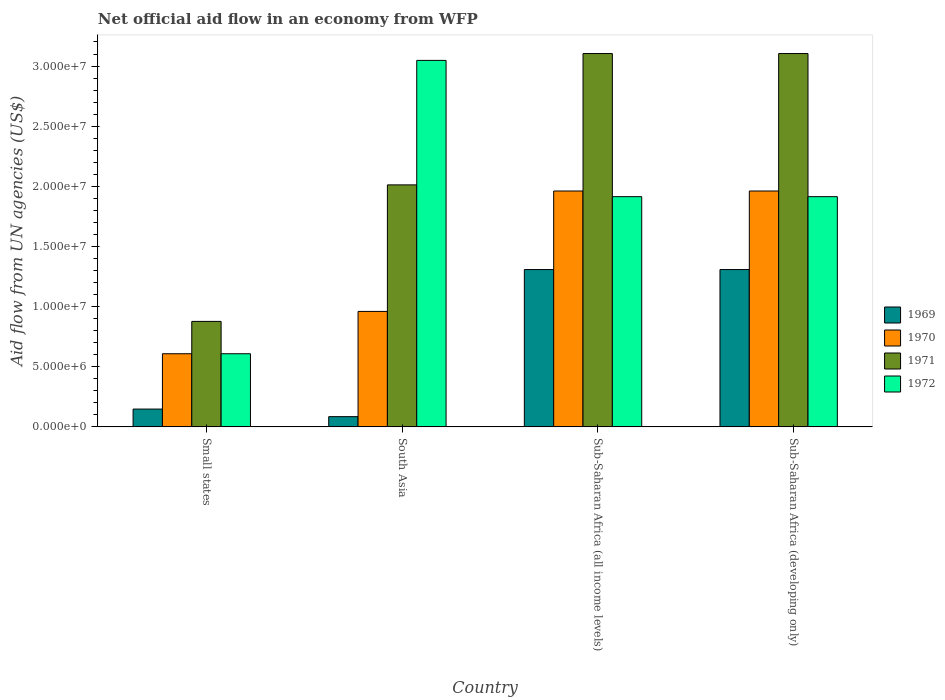Are the number of bars on each tick of the X-axis equal?
Make the answer very short. Yes. In how many cases, is the number of bars for a given country not equal to the number of legend labels?
Give a very brief answer. 0. What is the net official aid flow in 1970 in Small states?
Provide a short and direct response. 6.08e+06. Across all countries, what is the maximum net official aid flow in 1970?
Your response must be concise. 1.96e+07. Across all countries, what is the minimum net official aid flow in 1970?
Give a very brief answer. 6.08e+06. In which country was the net official aid flow in 1970 maximum?
Offer a terse response. Sub-Saharan Africa (all income levels). In which country was the net official aid flow in 1970 minimum?
Your answer should be very brief. Small states. What is the total net official aid flow in 1972 in the graph?
Make the answer very short. 7.48e+07. What is the difference between the net official aid flow in 1972 in Small states and that in South Asia?
Ensure brevity in your answer.  -2.44e+07. What is the difference between the net official aid flow in 1971 in Sub-Saharan Africa (all income levels) and the net official aid flow in 1969 in Small states?
Make the answer very short. 2.96e+07. What is the average net official aid flow in 1969 per country?
Give a very brief answer. 7.12e+06. What is the difference between the net official aid flow of/in 1972 and net official aid flow of/in 1971 in South Asia?
Your response must be concise. 1.04e+07. What is the ratio of the net official aid flow in 1972 in South Asia to that in Sub-Saharan Africa (all income levels)?
Your answer should be very brief. 1.59. Is the net official aid flow in 1970 in South Asia less than that in Sub-Saharan Africa (all income levels)?
Give a very brief answer. Yes. What is the difference between the highest and the second highest net official aid flow in 1971?
Your answer should be compact. 1.09e+07. What is the difference between the highest and the lowest net official aid flow in 1971?
Ensure brevity in your answer.  2.23e+07. Is the sum of the net official aid flow in 1970 in Small states and South Asia greater than the maximum net official aid flow in 1969 across all countries?
Ensure brevity in your answer.  Yes. Is it the case that in every country, the sum of the net official aid flow in 1969 and net official aid flow in 1970 is greater than the sum of net official aid flow in 1971 and net official aid flow in 1972?
Give a very brief answer. No. What does the 2nd bar from the right in South Asia represents?
Make the answer very short. 1971. Is it the case that in every country, the sum of the net official aid flow in 1972 and net official aid flow in 1969 is greater than the net official aid flow in 1970?
Your answer should be very brief. Yes. How many bars are there?
Your answer should be compact. 16. Are all the bars in the graph horizontal?
Offer a very short reply. No. Does the graph contain grids?
Provide a succinct answer. No. Where does the legend appear in the graph?
Offer a terse response. Center right. How many legend labels are there?
Your answer should be very brief. 4. How are the legend labels stacked?
Your answer should be very brief. Vertical. What is the title of the graph?
Offer a very short reply. Net official aid flow in an economy from WFP. Does "1974" appear as one of the legend labels in the graph?
Offer a terse response. No. What is the label or title of the X-axis?
Ensure brevity in your answer.  Country. What is the label or title of the Y-axis?
Your answer should be very brief. Aid flow from UN agencies (US$). What is the Aid flow from UN agencies (US$) in 1969 in Small states?
Keep it short and to the point. 1.48e+06. What is the Aid flow from UN agencies (US$) in 1970 in Small states?
Ensure brevity in your answer.  6.08e+06. What is the Aid flow from UN agencies (US$) in 1971 in Small states?
Your response must be concise. 8.77e+06. What is the Aid flow from UN agencies (US$) of 1972 in Small states?
Make the answer very short. 6.08e+06. What is the Aid flow from UN agencies (US$) of 1969 in South Asia?
Offer a terse response. 8.50e+05. What is the Aid flow from UN agencies (US$) of 1970 in South Asia?
Provide a succinct answer. 9.60e+06. What is the Aid flow from UN agencies (US$) in 1971 in South Asia?
Offer a very short reply. 2.01e+07. What is the Aid flow from UN agencies (US$) in 1972 in South Asia?
Your response must be concise. 3.05e+07. What is the Aid flow from UN agencies (US$) in 1969 in Sub-Saharan Africa (all income levels)?
Offer a terse response. 1.31e+07. What is the Aid flow from UN agencies (US$) in 1970 in Sub-Saharan Africa (all income levels)?
Your response must be concise. 1.96e+07. What is the Aid flow from UN agencies (US$) in 1971 in Sub-Saharan Africa (all income levels)?
Make the answer very short. 3.10e+07. What is the Aid flow from UN agencies (US$) in 1972 in Sub-Saharan Africa (all income levels)?
Make the answer very short. 1.91e+07. What is the Aid flow from UN agencies (US$) in 1969 in Sub-Saharan Africa (developing only)?
Keep it short and to the point. 1.31e+07. What is the Aid flow from UN agencies (US$) in 1970 in Sub-Saharan Africa (developing only)?
Your answer should be very brief. 1.96e+07. What is the Aid flow from UN agencies (US$) in 1971 in Sub-Saharan Africa (developing only)?
Your response must be concise. 3.10e+07. What is the Aid flow from UN agencies (US$) in 1972 in Sub-Saharan Africa (developing only)?
Your answer should be compact. 1.91e+07. Across all countries, what is the maximum Aid flow from UN agencies (US$) in 1969?
Your response must be concise. 1.31e+07. Across all countries, what is the maximum Aid flow from UN agencies (US$) in 1970?
Offer a terse response. 1.96e+07. Across all countries, what is the maximum Aid flow from UN agencies (US$) of 1971?
Offer a very short reply. 3.10e+07. Across all countries, what is the maximum Aid flow from UN agencies (US$) of 1972?
Ensure brevity in your answer.  3.05e+07. Across all countries, what is the minimum Aid flow from UN agencies (US$) of 1969?
Provide a short and direct response. 8.50e+05. Across all countries, what is the minimum Aid flow from UN agencies (US$) in 1970?
Your answer should be compact. 6.08e+06. Across all countries, what is the minimum Aid flow from UN agencies (US$) in 1971?
Make the answer very short. 8.77e+06. Across all countries, what is the minimum Aid flow from UN agencies (US$) in 1972?
Offer a terse response. 6.08e+06. What is the total Aid flow from UN agencies (US$) of 1969 in the graph?
Offer a terse response. 2.85e+07. What is the total Aid flow from UN agencies (US$) of 1970 in the graph?
Offer a very short reply. 5.49e+07. What is the total Aid flow from UN agencies (US$) of 1971 in the graph?
Ensure brevity in your answer.  9.10e+07. What is the total Aid flow from UN agencies (US$) of 1972 in the graph?
Give a very brief answer. 7.48e+07. What is the difference between the Aid flow from UN agencies (US$) of 1969 in Small states and that in South Asia?
Your answer should be compact. 6.30e+05. What is the difference between the Aid flow from UN agencies (US$) in 1970 in Small states and that in South Asia?
Your answer should be compact. -3.52e+06. What is the difference between the Aid flow from UN agencies (US$) in 1971 in Small states and that in South Asia?
Give a very brief answer. -1.14e+07. What is the difference between the Aid flow from UN agencies (US$) of 1972 in Small states and that in South Asia?
Make the answer very short. -2.44e+07. What is the difference between the Aid flow from UN agencies (US$) in 1969 in Small states and that in Sub-Saharan Africa (all income levels)?
Offer a terse response. -1.16e+07. What is the difference between the Aid flow from UN agencies (US$) of 1970 in Small states and that in Sub-Saharan Africa (all income levels)?
Make the answer very short. -1.35e+07. What is the difference between the Aid flow from UN agencies (US$) in 1971 in Small states and that in Sub-Saharan Africa (all income levels)?
Offer a very short reply. -2.23e+07. What is the difference between the Aid flow from UN agencies (US$) in 1972 in Small states and that in Sub-Saharan Africa (all income levels)?
Offer a very short reply. -1.31e+07. What is the difference between the Aid flow from UN agencies (US$) of 1969 in Small states and that in Sub-Saharan Africa (developing only)?
Give a very brief answer. -1.16e+07. What is the difference between the Aid flow from UN agencies (US$) in 1970 in Small states and that in Sub-Saharan Africa (developing only)?
Ensure brevity in your answer.  -1.35e+07. What is the difference between the Aid flow from UN agencies (US$) of 1971 in Small states and that in Sub-Saharan Africa (developing only)?
Provide a succinct answer. -2.23e+07. What is the difference between the Aid flow from UN agencies (US$) in 1972 in Small states and that in Sub-Saharan Africa (developing only)?
Your answer should be very brief. -1.31e+07. What is the difference between the Aid flow from UN agencies (US$) of 1969 in South Asia and that in Sub-Saharan Africa (all income levels)?
Your answer should be very brief. -1.22e+07. What is the difference between the Aid flow from UN agencies (US$) in 1970 in South Asia and that in Sub-Saharan Africa (all income levels)?
Your answer should be very brief. -1.00e+07. What is the difference between the Aid flow from UN agencies (US$) in 1971 in South Asia and that in Sub-Saharan Africa (all income levels)?
Give a very brief answer. -1.09e+07. What is the difference between the Aid flow from UN agencies (US$) in 1972 in South Asia and that in Sub-Saharan Africa (all income levels)?
Ensure brevity in your answer.  1.13e+07. What is the difference between the Aid flow from UN agencies (US$) in 1969 in South Asia and that in Sub-Saharan Africa (developing only)?
Your answer should be very brief. -1.22e+07. What is the difference between the Aid flow from UN agencies (US$) in 1970 in South Asia and that in Sub-Saharan Africa (developing only)?
Offer a very short reply. -1.00e+07. What is the difference between the Aid flow from UN agencies (US$) of 1971 in South Asia and that in Sub-Saharan Africa (developing only)?
Provide a succinct answer. -1.09e+07. What is the difference between the Aid flow from UN agencies (US$) in 1972 in South Asia and that in Sub-Saharan Africa (developing only)?
Your answer should be compact. 1.13e+07. What is the difference between the Aid flow from UN agencies (US$) of 1972 in Sub-Saharan Africa (all income levels) and that in Sub-Saharan Africa (developing only)?
Offer a terse response. 0. What is the difference between the Aid flow from UN agencies (US$) in 1969 in Small states and the Aid flow from UN agencies (US$) in 1970 in South Asia?
Offer a very short reply. -8.12e+06. What is the difference between the Aid flow from UN agencies (US$) in 1969 in Small states and the Aid flow from UN agencies (US$) in 1971 in South Asia?
Keep it short and to the point. -1.86e+07. What is the difference between the Aid flow from UN agencies (US$) in 1969 in Small states and the Aid flow from UN agencies (US$) in 1972 in South Asia?
Give a very brief answer. -2.90e+07. What is the difference between the Aid flow from UN agencies (US$) in 1970 in Small states and the Aid flow from UN agencies (US$) in 1971 in South Asia?
Provide a succinct answer. -1.40e+07. What is the difference between the Aid flow from UN agencies (US$) of 1970 in Small states and the Aid flow from UN agencies (US$) of 1972 in South Asia?
Offer a very short reply. -2.44e+07. What is the difference between the Aid flow from UN agencies (US$) of 1971 in Small states and the Aid flow from UN agencies (US$) of 1972 in South Asia?
Your answer should be compact. -2.17e+07. What is the difference between the Aid flow from UN agencies (US$) of 1969 in Small states and the Aid flow from UN agencies (US$) of 1970 in Sub-Saharan Africa (all income levels)?
Give a very brief answer. -1.81e+07. What is the difference between the Aid flow from UN agencies (US$) in 1969 in Small states and the Aid flow from UN agencies (US$) in 1971 in Sub-Saharan Africa (all income levels)?
Offer a very short reply. -2.96e+07. What is the difference between the Aid flow from UN agencies (US$) of 1969 in Small states and the Aid flow from UN agencies (US$) of 1972 in Sub-Saharan Africa (all income levels)?
Give a very brief answer. -1.77e+07. What is the difference between the Aid flow from UN agencies (US$) of 1970 in Small states and the Aid flow from UN agencies (US$) of 1971 in Sub-Saharan Africa (all income levels)?
Keep it short and to the point. -2.50e+07. What is the difference between the Aid flow from UN agencies (US$) in 1970 in Small states and the Aid flow from UN agencies (US$) in 1972 in Sub-Saharan Africa (all income levels)?
Make the answer very short. -1.31e+07. What is the difference between the Aid flow from UN agencies (US$) of 1971 in Small states and the Aid flow from UN agencies (US$) of 1972 in Sub-Saharan Africa (all income levels)?
Give a very brief answer. -1.04e+07. What is the difference between the Aid flow from UN agencies (US$) of 1969 in Small states and the Aid flow from UN agencies (US$) of 1970 in Sub-Saharan Africa (developing only)?
Make the answer very short. -1.81e+07. What is the difference between the Aid flow from UN agencies (US$) in 1969 in Small states and the Aid flow from UN agencies (US$) in 1971 in Sub-Saharan Africa (developing only)?
Your response must be concise. -2.96e+07. What is the difference between the Aid flow from UN agencies (US$) in 1969 in Small states and the Aid flow from UN agencies (US$) in 1972 in Sub-Saharan Africa (developing only)?
Offer a terse response. -1.77e+07. What is the difference between the Aid flow from UN agencies (US$) of 1970 in Small states and the Aid flow from UN agencies (US$) of 1971 in Sub-Saharan Africa (developing only)?
Keep it short and to the point. -2.50e+07. What is the difference between the Aid flow from UN agencies (US$) of 1970 in Small states and the Aid flow from UN agencies (US$) of 1972 in Sub-Saharan Africa (developing only)?
Ensure brevity in your answer.  -1.31e+07. What is the difference between the Aid flow from UN agencies (US$) in 1971 in Small states and the Aid flow from UN agencies (US$) in 1972 in Sub-Saharan Africa (developing only)?
Your answer should be compact. -1.04e+07. What is the difference between the Aid flow from UN agencies (US$) in 1969 in South Asia and the Aid flow from UN agencies (US$) in 1970 in Sub-Saharan Africa (all income levels)?
Your answer should be compact. -1.88e+07. What is the difference between the Aid flow from UN agencies (US$) in 1969 in South Asia and the Aid flow from UN agencies (US$) in 1971 in Sub-Saharan Africa (all income levels)?
Provide a succinct answer. -3.02e+07. What is the difference between the Aid flow from UN agencies (US$) of 1969 in South Asia and the Aid flow from UN agencies (US$) of 1972 in Sub-Saharan Africa (all income levels)?
Your answer should be very brief. -1.83e+07. What is the difference between the Aid flow from UN agencies (US$) of 1970 in South Asia and the Aid flow from UN agencies (US$) of 1971 in Sub-Saharan Africa (all income levels)?
Your response must be concise. -2.14e+07. What is the difference between the Aid flow from UN agencies (US$) of 1970 in South Asia and the Aid flow from UN agencies (US$) of 1972 in Sub-Saharan Africa (all income levels)?
Keep it short and to the point. -9.54e+06. What is the difference between the Aid flow from UN agencies (US$) of 1971 in South Asia and the Aid flow from UN agencies (US$) of 1972 in Sub-Saharan Africa (all income levels)?
Keep it short and to the point. 9.80e+05. What is the difference between the Aid flow from UN agencies (US$) in 1969 in South Asia and the Aid flow from UN agencies (US$) in 1970 in Sub-Saharan Africa (developing only)?
Your answer should be very brief. -1.88e+07. What is the difference between the Aid flow from UN agencies (US$) in 1969 in South Asia and the Aid flow from UN agencies (US$) in 1971 in Sub-Saharan Africa (developing only)?
Ensure brevity in your answer.  -3.02e+07. What is the difference between the Aid flow from UN agencies (US$) of 1969 in South Asia and the Aid flow from UN agencies (US$) of 1972 in Sub-Saharan Africa (developing only)?
Ensure brevity in your answer.  -1.83e+07. What is the difference between the Aid flow from UN agencies (US$) of 1970 in South Asia and the Aid flow from UN agencies (US$) of 1971 in Sub-Saharan Africa (developing only)?
Your answer should be very brief. -2.14e+07. What is the difference between the Aid flow from UN agencies (US$) of 1970 in South Asia and the Aid flow from UN agencies (US$) of 1972 in Sub-Saharan Africa (developing only)?
Keep it short and to the point. -9.54e+06. What is the difference between the Aid flow from UN agencies (US$) of 1971 in South Asia and the Aid flow from UN agencies (US$) of 1972 in Sub-Saharan Africa (developing only)?
Provide a succinct answer. 9.80e+05. What is the difference between the Aid flow from UN agencies (US$) of 1969 in Sub-Saharan Africa (all income levels) and the Aid flow from UN agencies (US$) of 1970 in Sub-Saharan Africa (developing only)?
Provide a succinct answer. -6.53e+06. What is the difference between the Aid flow from UN agencies (US$) in 1969 in Sub-Saharan Africa (all income levels) and the Aid flow from UN agencies (US$) in 1971 in Sub-Saharan Africa (developing only)?
Make the answer very short. -1.80e+07. What is the difference between the Aid flow from UN agencies (US$) in 1969 in Sub-Saharan Africa (all income levels) and the Aid flow from UN agencies (US$) in 1972 in Sub-Saharan Africa (developing only)?
Give a very brief answer. -6.06e+06. What is the difference between the Aid flow from UN agencies (US$) of 1970 in Sub-Saharan Africa (all income levels) and the Aid flow from UN agencies (US$) of 1971 in Sub-Saharan Africa (developing only)?
Make the answer very short. -1.14e+07. What is the difference between the Aid flow from UN agencies (US$) in 1970 in Sub-Saharan Africa (all income levels) and the Aid flow from UN agencies (US$) in 1972 in Sub-Saharan Africa (developing only)?
Keep it short and to the point. 4.70e+05. What is the difference between the Aid flow from UN agencies (US$) in 1971 in Sub-Saharan Africa (all income levels) and the Aid flow from UN agencies (US$) in 1972 in Sub-Saharan Africa (developing only)?
Keep it short and to the point. 1.19e+07. What is the average Aid flow from UN agencies (US$) of 1969 per country?
Your response must be concise. 7.12e+06. What is the average Aid flow from UN agencies (US$) of 1970 per country?
Make the answer very short. 1.37e+07. What is the average Aid flow from UN agencies (US$) of 1971 per country?
Provide a succinct answer. 2.27e+07. What is the average Aid flow from UN agencies (US$) of 1972 per country?
Provide a short and direct response. 1.87e+07. What is the difference between the Aid flow from UN agencies (US$) of 1969 and Aid flow from UN agencies (US$) of 1970 in Small states?
Your answer should be very brief. -4.60e+06. What is the difference between the Aid flow from UN agencies (US$) in 1969 and Aid flow from UN agencies (US$) in 1971 in Small states?
Ensure brevity in your answer.  -7.29e+06. What is the difference between the Aid flow from UN agencies (US$) of 1969 and Aid flow from UN agencies (US$) of 1972 in Small states?
Keep it short and to the point. -4.60e+06. What is the difference between the Aid flow from UN agencies (US$) in 1970 and Aid flow from UN agencies (US$) in 1971 in Small states?
Provide a short and direct response. -2.69e+06. What is the difference between the Aid flow from UN agencies (US$) of 1970 and Aid flow from UN agencies (US$) of 1972 in Small states?
Your response must be concise. 0. What is the difference between the Aid flow from UN agencies (US$) of 1971 and Aid flow from UN agencies (US$) of 1972 in Small states?
Offer a very short reply. 2.69e+06. What is the difference between the Aid flow from UN agencies (US$) of 1969 and Aid flow from UN agencies (US$) of 1970 in South Asia?
Offer a terse response. -8.75e+06. What is the difference between the Aid flow from UN agencies (US$) in 1969 and Aid flow from UN agencies (US$) in 1971 in South Asia?
Make the answer very short. -1.93e+07. What is the difference between the Aid flow from UN agencies (US$) of 1969 and Aid flow from UN agencies (US$) of 1972 in South Asia?
Offer a very short reply. -2.96e+07. What is the difference between the Aid flow from UN agencies (US$) of 1970 and Aid flow from UN agencies (US$) of 1971 in South Asia?
Your response must be concise. -1.05e+07. What is the difference between the Aid flow from UN agencies (US$) in 1970 and Aid flow from UN agencies (US$) in 1972 in South Asia?
Offer a very short reply. -2.09e+07. What is the difference between the Aid flow from UN agencies (US$) of 1971 and Aid flow from UN agencies (US$) of 1972 in South Asia?
Your answer should be compact. -1.04e+07. What is the difference between the Aid flow from UN agencies (US$) of 1969 and Aid flow from UN agencies (US$) of 1970 in Sub-Saharan Africa (all income levels)?
Give a very brief answer. -6.53e+06. What is the difference between the Aid flow from UN agencies (US$) of 1969 and Aid flow from UN agencies (US$) of 1971 in Sub-Saharan Africa (all income levels)?
Keep it short and to the point. -1.80e+07. What is the difference between the Aid flow from UN agencies (US$) in 1969 and Aid flow from UN agencies (US$) in 1972 in Sub-Saharan Africa (all income levels)?
Give a very brief answer. -6.06e+06. What is the difference between the Aid flow from UN agencies (US$) of 1970 and Aid flow from UN agencies (US$) of 1971 in Sub-Saharan Africa (all income levels)?
Make the answer very short. -1.14e+07. What is the difference between the Aid flow from UN agencies (US$) in 1971 and Aid flow from UN agencies (US$) in 1972 in Sub-Saharan Africa (all income levels)?
Your answer should be very brief. 1.19e+07. What is the difference between the Aid flow from UN agencies (US$) in 1969 and Aid flow from UN agencies (US$) in 1970 in Sub-Saharan Africa (developing only)?
Ensure brevity in your answer.  -6.53e+06. What is the difference between the Aid flow from UN agencies (US$) of 1969 and Aid flow from UN agencies (US$) of 1971 in Sub-Saharan Africa (developing only)?
Give a very brief answer. -1.80e+07. What is the difference between the Aid flow from UN agencies (US$) in 1969 and Aid flow from UN agencies (US$) in 1972 in Sub-Saharan Africa (developing only)?
Keep it short and to the point. -6.06e+06. What is the difference between the Aid flow from UN agencies (US$) of 1970 and Aid flow from UN agencies (US$) of 1971 in Sub-Saharan Africa (developing only)?
Your answer should be very brief. -1.14e+07. What is the difference between the Aid flow from UN agencies (US$) in 1971 and Aid flow from UN agencies (US$) in 1972 in Sub-Saharan Africa (developing only)?
Ensure brevity in your answer.  1.19e+07. What is the ratio of the Aid flow from UN agencies (US$) in 1969 in Small states to that in South Asia?
Your answer should be very brief. 1.74. What is the ratio of the Aid flow from UN agencies (US$) of 1970 in Small states to that in South Asia?
Your answer should be very brief. 0.63. What is the ratio of the Aid flow from UN agencies (US$) in 1971 in Small states to that in South Asia?
Your answer should be very brief. 0.44. What is the ratio of the Aid flow from UN agencies (US$) in 1972 in Small states to that in South Asia?
Ensure brevity in your answer.  0.2. What is the ratio of the Aid flow from UN agencies (US$) of 1969 in Small states to that in Sub-Saharan Africa (all income levels)?
Your answer should be compact. 0.11. What is the ratio of the Aid flow from UN agencies (US$) of 1970 in Small states to that in Sub-Saharan Africa (all income levels)?
Make the answer very short. 0.31. What is the ratio of the Aid flow from UN agencies (US$) of 1971 in Small states to that in Sub-Saharan Africa (all income levels)?
Your answer should be very brief. 0.28. What is the ratio of the Aid flow from UN agencies (US$) in 1972 in Small states to that in Sub-Saharan Africa (all income levels)?
Provide a short and direct response. 0.32. What is the ratio of the Aid flow from UN agencies (US$) in 1969 in Small states to that in Sub-Saharan Africa (developing only)?
Provide a short and direct response. 0.11. What is the ratio of the Aid flow from UN agencies (US$) in 1970 in Small states to that in Sub-Saharan Africa (developing only)?
Offer a terse response. 0.31. What is the ratio of the Aid flow from UN agencies (US$) in 1971 in Small states to that in Sub-Saharan Africa (developing only)?
Provide a succinct answer. 0.28. What is the ratio of the Aid flow from UN agencies (US$) in 1972 in Small states to that in Sub-Saharan Africa (developing only)?
Your response must be concise. 0.32. What is the ratio of the Aid flow from UN agencies (US$) in 1969 in South Asia to that in Sub-Saharan Africa (all income levels)?
Your response must be concise. 0.07. What is the ratio of the Aid flow from UN agencies (US$) of 1970 in South Asia to that in Sub-Saharan Africa (all income levels)?
Offer a terse response. 0.49. What is the ratio of the Aid flow from UN agencies (US$) in 1971 in South Asia to that in Sub-Saharan Africa (all income levels)?
Keep it short and to the point. 0.65. What is the ratio of the Aid flow from UN agencies (US$) in 1972 in South Asia to that in Sub-Saharan Africa (all income levels)?
Your answer should be very brief. 1.59. What is the ratio of the Aid flow from UN agencies (US$) of 1969 in South Asia to that in Sub-Saharan Africa (developing only)?
Ensure brevity in your answer.  0.07. What is the ratio of the Aid flow from UN agencies (US$) of 1970 in South Asia to that in Sub-Saharan Africa (developing only)?
Give a very brief answer. 0.49. What is the ratio of the Aid flow from UN agencies (US$) in 1971 in South Asia to that in Sub-Saharan Africa (developing only)?
Offer a very short reply. 0.65. What is the ratio of the Aid flow from UN agencies (US$) of 1972 in South Asia to that in Sub-Saharan Africa (developing only)?
Provide a succinct answer. 1.59. What is the ratio of the Aid flow from UN agencies (US$) in 1970 in Sub-Saharan Africa (all income levels) to that in Sub-Saharan Africa (developing only)?
Offer a terse response. 1. What is the ratio of the Aid flow from UN agencies (US$) of 1971 in Sub-Saharan Africa (all income levels) to that in Sub-Saharan Africa (developing only)?
Give a very brief answer. 1. What is the difference between the highest and the second highest Aid flow from UN agencies (US$) of 1971?
Provide a succinct answer. 0. What is the difference between the highest and the second highest Aid flow from UN agencies (US$) in 1972?
Provide a succinct answer. 1.13e+07. What is the difference between the highest and the lowest Aid flow from UN agencies (US$) in 1969?
Your answer should be very brief. 1.22e+07. What is the difference between the highest and the lowest Aid flow from UN agencies (US$) of 1970?
Provide a short and direct response. 1.35e+07. What is the difference between the highest and the lowest Aid flow from UN agencies (US$) in 1971?
Keep it short and to the point. 2.23e+07. What is the difference between the highest and the lowest Aid flow from UN agencies (US$) of 1972?
Make the answer very short. 2.44e+07. 